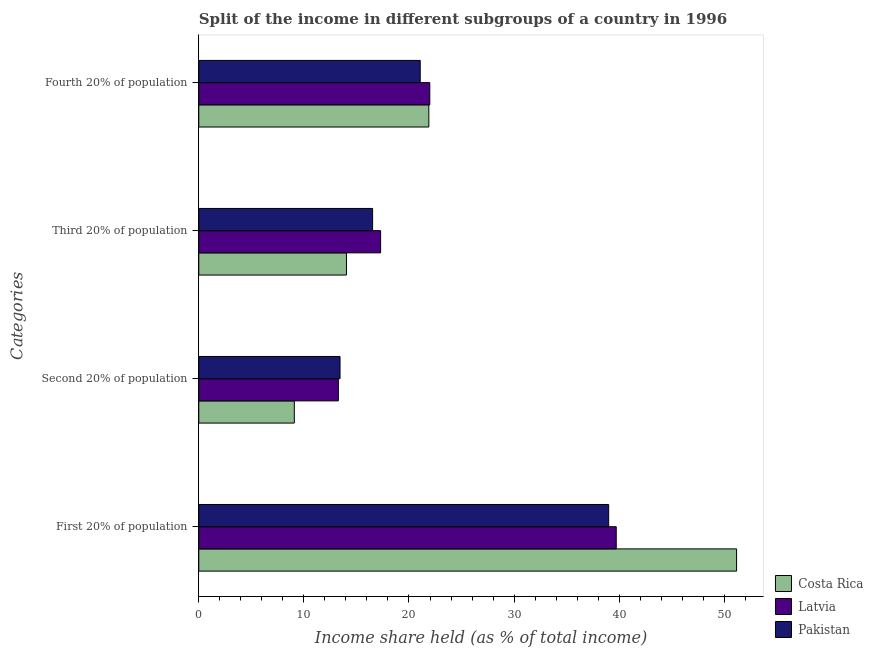How many bars are there on the 1st tick from the top?
Your answer should be compact. 3. What is the label of the 1st group of bars from the top?
Ensure brevity in your answer.  Fourth 20% of population. What is the share of the income held by second 20% of the population in Costa Rica?
Provide a short and direct response. 9.09. Across all countries, what is the maximum share of the income held by second 20% of the population?
Make the answer very short. 13.44. Across all countries, what is the minimum share of the income held by fourth 20% of the population?
Your response must be concise. 21.07. In which country was the share of the income held by first 20% of the population maximum?
Keep it short and to the point. Costa Rica. What is the total share of the income held by second 20% of the population in the graph?
Keep it short and to the point. 35.81. What is the difference between the share of the income held by fourth 20% of the population in Latvia and that in Pakistan?
Your answer should be compact. 0.91. What is the difference between the share of the income held by fourth 20% of the population in Pakistan and the share of the income held by third 20% of the population in Costa Rica?
Ensure brevity in your answer.  7.02. What is the average share of the income held by second 20% of the population per country?
Offer a terse response. 11.94. What is the difference between the share of the income held by third 20% of the population and share of the income held by first 20% of the population in Costa Rica?
Ensure brevity in your answer.  -37.12. In how many countries, is the share of the income held by fourth 20% of the population greater than 44 %?
Ensure brevity in your answer.  0. What is the ratio of the share of the income held by fourth 20% of the population in Costa Rica to that in Pakistan?
Provide a succinct answer. 1.04. Is the difference between the share of the income held by first 20% of the population in Costa Rica and Latvia greater than the difference between the share of the income held by fourth 20% of the population in Costa Rica and Latvia?
Offer a terse response. Yes. What is the difference between the highest and the second highest share of the income held by second 20% of the population?
Give a very brief answer. 0.16. Is the sum of the share of the income held by second 20% of the population in Costa Rica and Pakistan greater than the maximum share of the income held by fourth 20% of the population across all countries?
Offer a very short reply. Yes. Is it the case that in every country, the sum of the share of the income held by first 20% of the population and share of the income held by third 20% of the population is greater than the sum of share of the income held by fourth 20% of the population and share of the income held by second 20% of the population?
Ensure brevity in your answer.  Yes. What does the 2nd bar from the top in First 20% of population represents?
Make the answer very short. Latvia. What does the 1st bar from the bottom in Fourth 20% of population represents?
Give a very brief answer. Costa Rica. Is it the case that in every country, the sum of the share of the income held by first 20% of the population and share of the income held by second 20% of the population is greater than the share of the income held by third 20% of the population?
Give a very brief answer. Yes. What is the difference between two consecutive major ticks on the X-axis?
Offer a terse response. 10. Are the values on the major ticks of X-axis written in scientific E-notation?
Offer a very short reply. No. What is the title of the graph?
Provide a short and direct response. Split of the income in different subgroups of a country in 1996. Does "Lesotho" appear as one of the legend labels in the graph?
Your answer should be very brief. No. What is the label or title of the X-axis?
Offer a terse response. Income share held (as % of total income). What is the label or title of the Y-axis?
Keep it short and to the point. Categories. What is the Income share held (as % of total income) in Costa Rica in First 20% of population?
Make the answer very short. 51.17. What is the Income share held (as % of total income) in Latvia in First 20% of population?
Offer a terse response. 39.72. What is the Income share held (as % of total income) in Pakistan in First 20% of population?
Provide a short and direct response. 39. What is the Income share held (as % of total income) of Costa Rica in Second 20% of population?
Provide a short and direct response. 9.09. What is the Income share held (as % of total income) in Latvia in Second 20% of population?
Provide a short and direct response. 13.28. What is the Income share held (as % of total income) of Pakistan in Second 20% of population?
Keep it short and to the point. 13.44. What is the Income share held (as % of total income) of Costa Rica in Third 20% of population?
Keep it short and to the point. 14.05. What is the Income share held (as % of total income) of Pakistan in Third 20% of population?
Keep it short and to the point. 16.54. What is the Income share held (as % of total income) in Costa Rica in Fourth 20% of population?
Your response must be concise. 21.89. What is the Income share held (as % of total income) in Latvia in Fourth 20% of population?
Your answer should be very brief. 21.98. What is the Income share held (as % of total income) of Pakistan in Fourth 20% of population?
Give a very brief answer. 21.07. Across all Categories, what is the maximum Income share held (as % of total income) in Costa Rica?
Give a very brief answer. 51.17. Across all Categories, what is the maximum Income share held (as % of total income) in Latvia?
Keep it short and to the point. 39.72. Across all Categories, what is the minimum Income share held (as % of total income) in Costa Rica?
Provide a short and direct response. 9.09. Across all Categories, what is the minimum Income share held (as % of total income) of Latvia?
Your answer should be compact. 13.28. Across all Categories, what is the minimum Income share held (as % of total income) of Pakistan?
Ensure brevity in your answer.  13.44. What is the total Income share held (as % of total income) in Costa Rica in the graph?
Provide a short and direct response. 96.2. What is the total Income share held (as % of total income) in Latvia in the graph?
Make the answer very short. 92.28. What is the total Income share held (as % of total income) of Pakistan in the graph?
Provide a succinct answer. 90.05. What is the difference between the Income share held (as % of total income) of Costa Rica in First 20% of population and that in Second 20% of population?
Give a very brief answer. 42.08. What is the difference between the Income share held (as % of total income) of Latvia in First 20% of population and that in Second 20% of population?
Provide a succinct answer. 26.44. What is the difference between the Income share held (as % of total income) in Pakistan in First 20% of population and that in Second 20% of population?
Provide a short and direct response. 25.56. What is the difference between the Income share held (as % of total income) in Costa Rica in First 20% of population and that in Third 20% of population?
Provide a succinct answer. 37.12. What is the difference between the Income share held (as % of total income) in Latvia in First 20% of population and that in Third 20% of population?
Keep it short and to the point. 22.42. What is the difference between the Income share held (as % of total income) of Pakistan in First 20% of population and that in Third 20% of population?
Provide a short and direct response. 22.46. What is the difference between the Income share held (as % of total income) of Costa Rica in First 20% of population and that in Fourth 20% of population?
Give a very brief answer. 29.28. What is the difference between the Income share held (as % of total income) in Latvia in First 20% of population and that in Fourth 20% of population?
Provide a succinct answer. 17.74. What is the difference between the Income share held (as % of total income) in Pakistan in First 20% of population and that in Fourth 20% of population?
Provide a succinct answer. 17.93. What is the difference between the Income share held (as % of total income) of Costa Rica in Second 20% of population and that in Third 20% of population?
Your response must be concise. -4.96. What is the difference between the Income share held (as % of total income) in Latvia in Second 20% of population and that in Third 20% of population?
Give a very brief answer. -4.02. What is the difference between the Income share held (as % of total income) of Pakistan in Second 20% of population and that in Third 20% of population?
Offer a very short reply. -3.1. What is the difference between the Income share held (as % of total income) of Pakistan in Second 20% of population and that in Fourth 20% of population?
Ensure brevity in your answer.  -7.63. What is the difference between the Income share held (as % of total income) of Costa Rica in Third 20% of population and that in Fourth 20% of population?
Keep it short and to the point. -7.84. What is the difference between the Income share held (as % of total income) in Latvia in Third 20% of population and that in Fourth 20% of population?
Your answer should be compact. -4.68. What is the difference between the Income share held (as % of total income) of Pakistan in Third 20% of population and that in Fourth 20% of population?
Provide a short and direct response. -4.53. What is the difference between the Income share held (as % of total income) in Costa Rica in First 20% of population and the Income share held (as % of total income) in Latvia in Second 20% of population?
Provide a succinct answer. 37.89. What is the difference between the Income share held (as % of total income) in Costa Rica in First 20% of population and the Income share held (as % of total income) in Pakistan in Second 20% of population?
Give a very brief answer. 37.73. What is the difference between the Income share held (as % of total income) of Latvia in First 20% of population and the Income share held (as % of total income) of Pakistan in Second 20% of population?
Your response must be concise. 26.28. What is the difference between the Income share held (as % of total income) in Costa Rica in First 20% of population and the Income share held (as % of total income) in Latvia in Third 20% of population?
Your answer should be compact. 33.87. What is the difference between the Income share held (as % of total income) in Costa Rica in First 20% of population and the Income share held (as % of total income) in Pakistan in Third 20% of population?
Your answer should be compact. 34.63. What is the difference between the Income share held (as % of total income) in Latvia in First 20% of population and the Income share held (as % of total income) in Pakistan in Third 20% of population?
Offer a terse response. 23.18. What is the difference between the Income share held (as % of total income) of Costa Rica in First 20% of population and the Income share held (as % of total income) of Latvia in Fourth 20% of population?
Provide a succinct answer. 29.19. What is the difference between the Income share held (as % of total income) in Costa Rica in First 20% of population and the Income share held (as % of total income) in Pakistan in Fourth 20% of population?
Offer a terse response. 30.1. What is the difference between the Income share held (as % of total income) of Latvia in First 20% of population and the Income share held (as % of total income) of Pakistan in Fourth 20% of population?
Offer a terse response. 18.65. What is the difference between the Income share held (as % of total income) of Costa Rica in Second 20% of population and the Income share held (as % of total income) of Latvia in Third 20% of population?
Provide a succinct answer. -8.21. What is the difference between the Income share held (as % of total income) of Costa Rica in Second 20% of population and the Income share held (as % of total income) of Pakistan in Third 20% of population?
Your answer should be compact. -7.45. What is the difference between the Income share held (as % of total income) in Latvia in Second 20% of population and the Income share held (as % of total income) in Pakistan in Third 20% of population?
Provide a succinct answer. -3.26. What is the difference between the Income share held (as % of total income) in Costa Rica in Second 20% of population and the Income share held (as % of total income) in Latvia in Fourth 20% of population?
Your answer should be very brief. -12.89. What is the difference between the Income share held (as % of total income) in Costa Rica in Second 20% of population and the Income share held (as % of total income) in Pakistan in Fourth 20% of population?
Offer a very short reply. -11.98. What is the difference between the Income share held (as % of total income) in Latvia in Second 20% of population and the Income share held (as % of total income) in Pakistan in Fourth 20% of population?
Your response must be concise. -7.79. What is the difference between the Income share held (as % of total income) of Costa Rica in Third 20% of population and the Income share held (as % of total income) of Latvia in Fourth 20% of population?
Offer a terse response. -7.93. What is the difference between the Income share held (as % of total income) of Costa Rica in Third 20% of population and the Income share held (as % of total income) of Pakistan in Fourth 20% of population?
Ensure brevity in your answer.  -7.02. What is the difference between the Income share held (as % of total income) of Latvia in Third 20% of population and the Income share held (as % of total income) of Pakistan in Fourth 20% of population?
Your response must be concise. -3.77. What is the average Income share held (as % of total income) in Costa Rica per Categories?
Provide a short and direct response. 24.05. What is the average Income share held (as % of total income) in Latvia per Categories?
Offer a very short reply. 23.07. What is the average Income share held (as % of total income) in Pakistan per Categories?
Provide a short and direct response. 22.51. What is the difference between the Income share held (as % of total income) in Costa Rica and Income share held (as % of total income) in Latvia in First 20% of population?
Offer a terse response. 11.45. What is the difference between the Income share held (as % of total income) in Costa Rica and Income share held (as % of total income) in Pakistan in First 20% of population?
Offer a terse response. 12.17. What is the difference between the Income share held (as % of total income) of Latvia and Income share held (as % of total income) of Pakistan in First 20% of population?
Your response must be concise. 0.72. What is the difference between the Income share held (as % of total income) in Costa Rica and Income share held (as % of total income) in Latvia in Second 20% of population?
Provide a succinct answer. -4.19. What is the difference between the Income share held (as % of total income) in Costa Rica and Income share held (as % of total income) in Pakistan in Second 20% of population?
Make the answer very short. -4.35. What is the difference between the Income share held (as % of total income) in Latvia and Income share held (as % of total income) in Pakistan in Second 20% of population?
Your answer should be very brief. -0.16. What is the difference between the Income share held (as % of total income) in Costa Rica and Income share held (as % of total income) in Latvia in Third 20% of population?
Provide a succinct answer. -3.25. What is the difference between the Income share held (as % of total income) in Costa Rica and Income share held (as % of total income) in Pakistan in Third 20% of population?
Your answer should be very brief. -2.49. What is the difference between the Income share held (as % of total income) of Latvia and Income share held (as % of total income) of Pakistan in Third 20% of population?
Give a very brief answer. 0.76. What is the difference between the Income share held (as % of total income) of Costa Rica and Income share held (as % of total income) of Latvia in Fourth 20% of population?
Offer a very short reply. -0.09. What is the difference between the Income share held (as % of total income) of Costa Rica and Income share held (as % of total income) of Pakistan in Fourth 20% of population?
Provide a succinct answer. 0.82. What is the difference between the Income share held (as % of total income) in Latvia and Income share held (as % of total income) in Pakistan in Fourth 20% of population?
Provide a succinct answer. 0.91. What is the ratio of the Income share held (as % of total income) in Costa Rica in First 20% of population to that in Second 20% of population?
Your response must be concise. 5.63. What is the ratio of the Income share held (as % of total income) of Latvia in First 20% of population to that in Second 20% of population?
Your answer should be very brief. 2.99. What is the ratio of the Income share held (as % of total income) in Pakistan in First 20% of population to that in Second 20% of population?
Provide a short and direct response. 2.9. What is the ratio of the Income share held (as % of total income) of Costa Rica in First 20% of population to that in Third 20% of population?
Offer a terse response. 3.64. What is the ratio of the Income share held (as % of total income) of Latvia in First 20% of population to that in Third 20% of population?
Give a very brief answer. 2.3. What is the ratio of the Income share held (as % of total income) of Pakistan in First 20% of population to that in Third 20% of population?
Your answer should be compact. 2.36. What is the ratio of the Income share held (as % of total income) of Costa Rica in First 20% of population to that in Fourth 20% of population?
Give a very brief answer. 2.34. What is the ratio of the Income share held (as % of total income) of Latvia in First 20% of population to that in Fourth 20% of population?
Ensure brevity in your answer.  1.81. What is the ratio of the Income share held (as % of total income) in Pakistan in First 20% of population to that in Fourth 20% of population?
Keep it short and to the point. 1.85. What is the ratio of the Income share held (as % of total income) of Costa Rica in Second 20% of population to that in Third 20% of population?
Your response must be concise. 0.65. What is the ratio of the Income share held (as % of total income) of Latvia in Second 20% of population to that in Third 20% of population?
Provide a succinct answer. 0.77. What is the ratio of the Income share held (as % of total income) of Pakistan in Second 20% of population to that in Third 20% of population?
Give a very brief answer. 0.81. What is the ratio of the Income share held (as % of total income) of Costa Rica in Second 20% of population to that in Fourth 20% of population?
Your answer should be very brief. 0.42. What is the ratio of the Income share held (as % of total income) of Latvia in Second 20% of population to that in Fourth 20% of population?
Give a very brief answer. 0.6. What is the ratio of the Income share held (as % of total income) of Pakistan in Second 20% of population to that in Fourth 20% of population?
Your response must be concise. 0.64. What is the ratio of the Income share held (as % of total income) of Costa Rica in Third 20% of population to that in Fourth 20% of population?
Your answer should be compact. 0.64. What is the ratio of the Income share held (as % of total income) of Latvia in Third 20% of population to that in Fourth 20% of population?
Keep it short and to the point. 0.79. What is the ratio of the Income share held (as % of total income) of Pakistan in Third 20% of population to that in Fourth 20% of population?
Provide a short and direct response. 0.79. What is the difference between the highest and the second highest Income share held (as % of total income) of Costa Rica?
Your answer should be compact. 29.28. What is the difference between the highest and the second highest Income share held (as % of total income) of Latvia?
Ensure brevity in your answer.  17.74. What is the difference between the highest and the second highest Income share held (as % of total income) in Pakistan?
Your answer should be compact. 17.93. What is the difference between the highest and the lowest Income share held (as % of total income) in Costa Rica?
Offer a terse response. 42.08. What is the difference between the highest and the lowest Income share held (as % of total income) in Latvia?
Ensure brevity in your answer.  26.44. What is the difference between the highest and the lowest Income share held (as % of total income) in Pakistan?
Keep it short and to the point. 25.56. 